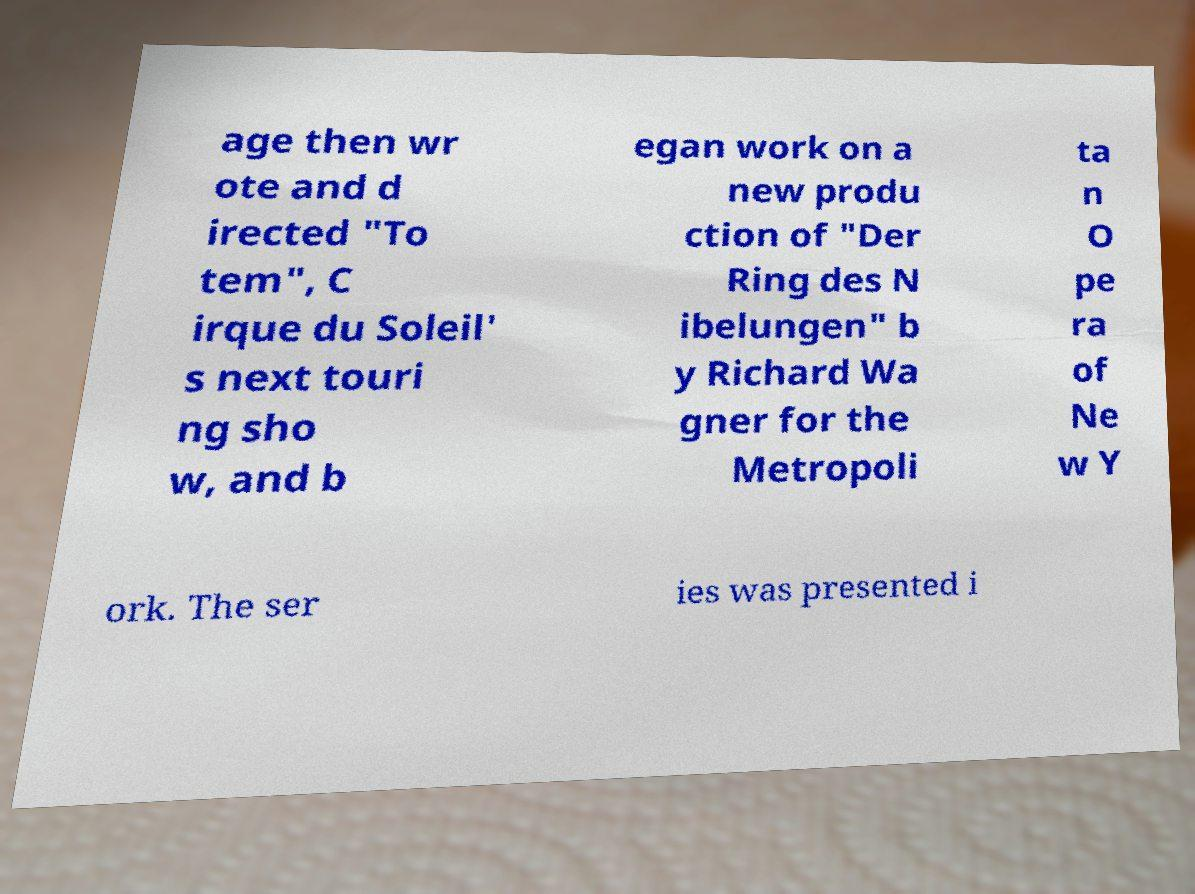Please identify and transcribe the text found in this image. age then wr ote and d irected "To tem", C irque du Soleil' s next touri ng sho w, and b egan work on a new produ ction of "Der Ring des N ibelungen" b y Richard Wa gner for the Metropoli ta n O pe ra of Ne w Y ork. The ser ies was presented i 